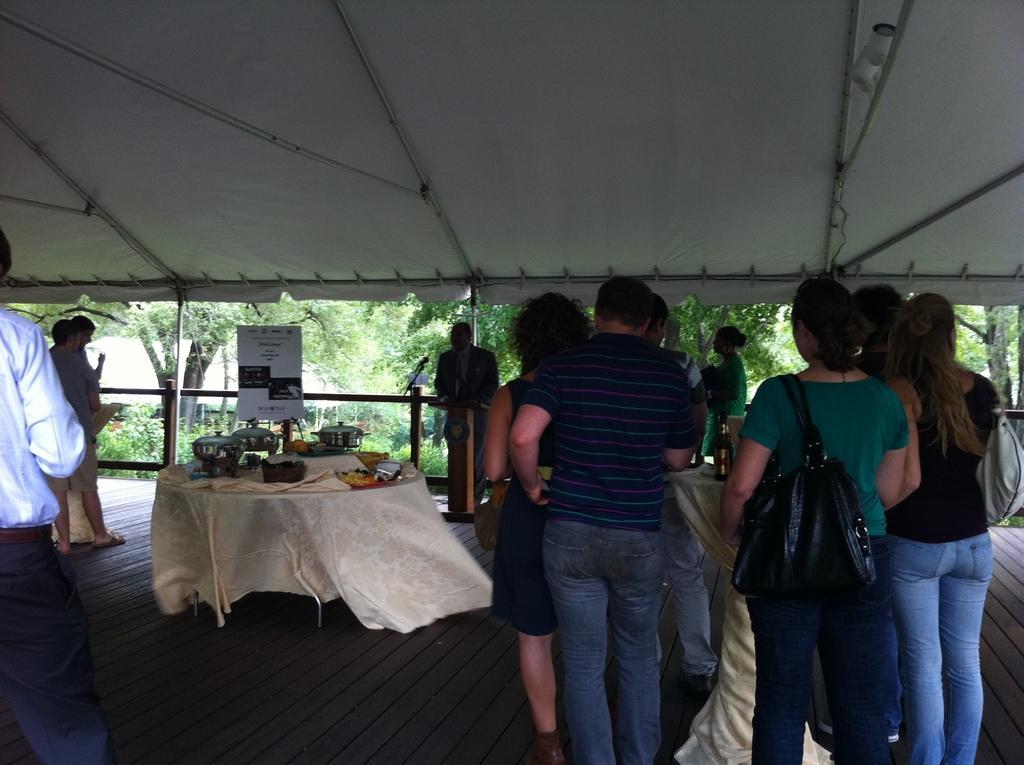Could you give a brief overview of what you see in this image? In this image I can see the group of people standing and wearing the different color dresses. I can see few people are wearing the bags. To the left I can see the table. On the table there are utensils and some objects. In the background I can see the board, railing and the trees. 